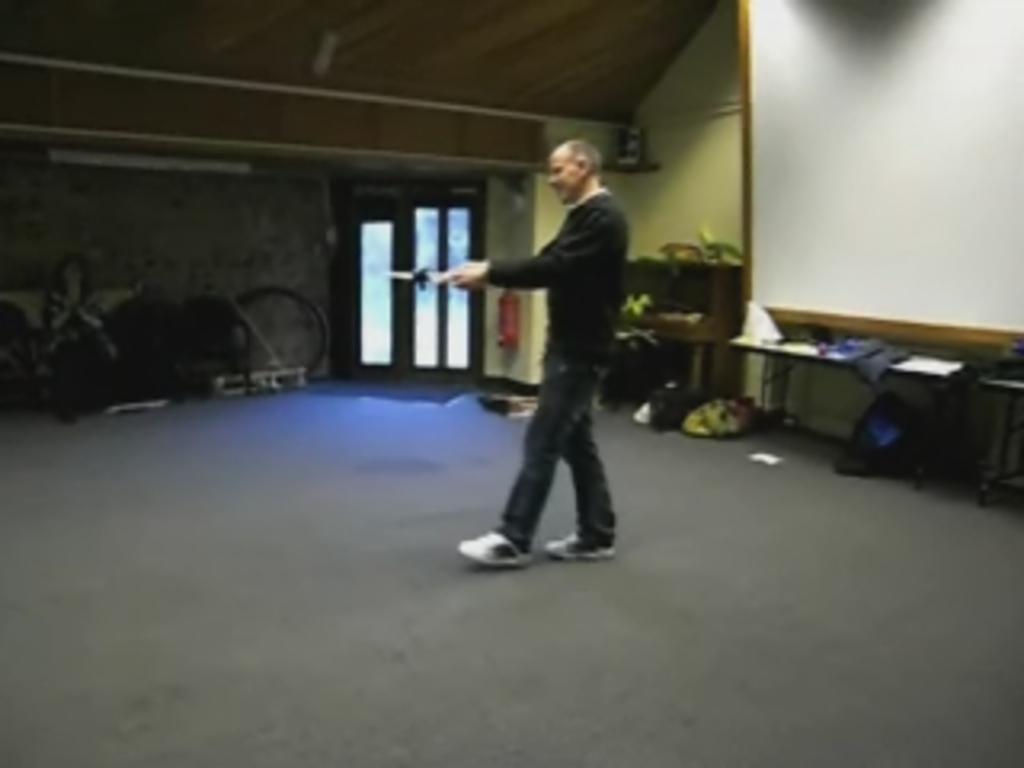Describe this image in one or two sentences. In this image we can see a man standing and holding an object, in the background there is a white color board, table and some objects. 